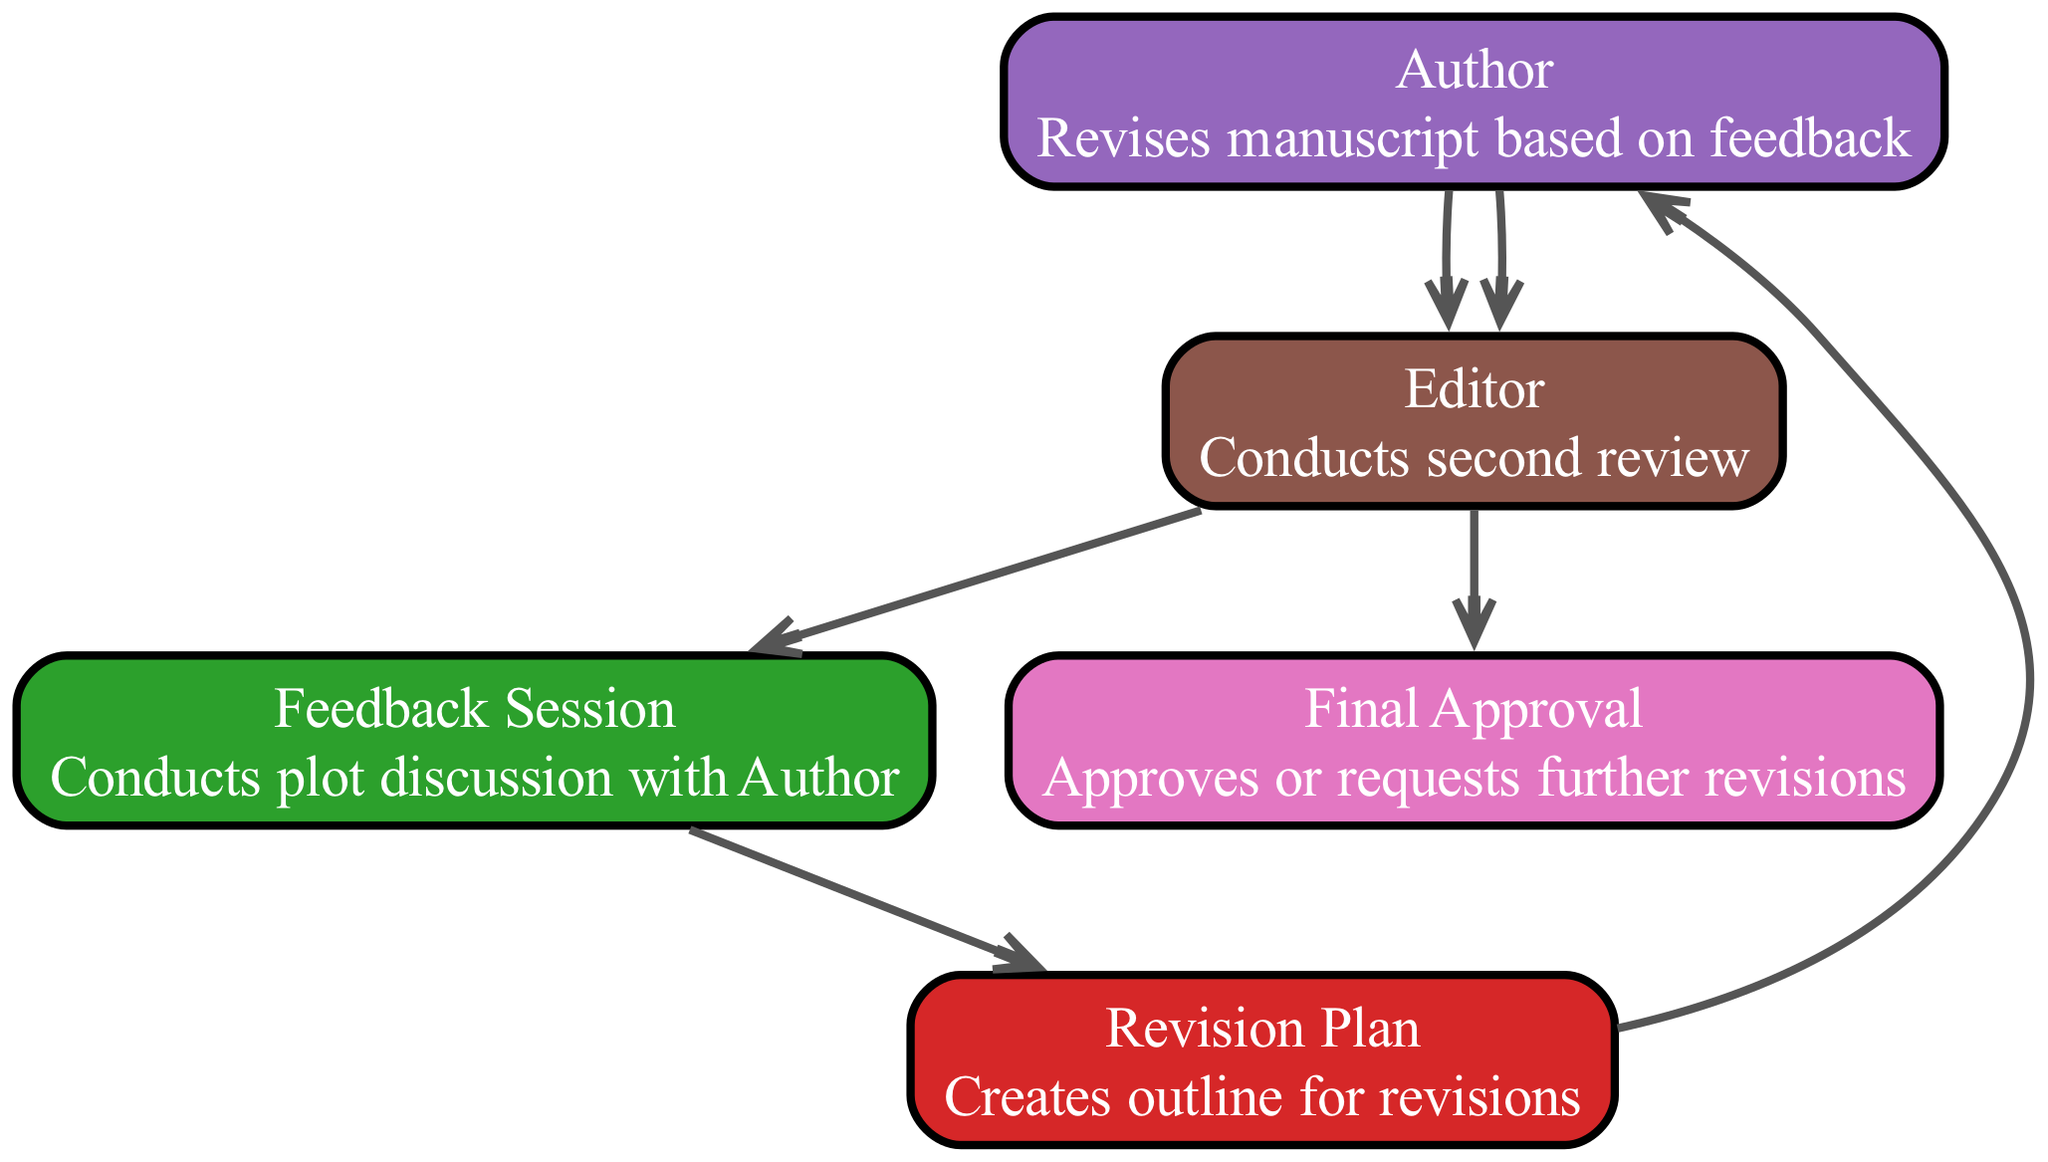What is the first action taken in the workflow? The first action in the diagram is by the Author, who submits the draft manuscript. This can be determined by looking at the starting node, which shows the Author taking the initial step.
Answer: Submits draft manuscript How many total elements are in the sequence diagram? By counting all the defined elements in the diagram, there are seven elements showcasing different actions by the Author, Editor, Feedback Session, Revision Plan, and Final Approval.
Answer: 7 What action follows the revision plan in the workflow? The action that follows the Revision Plan is the Author revises the manuscript based on feedback. This can be verified by examining the edges connecting the nodes.
Answer: Revises manuscript based on feedback Which element acts as a decision point in the workflow? The Final Approval acts as a decision point, as it either approves or requests further revisions based on the previous actions. This is indicated by it being the last element connected decisively to prior actions.
Answer: Final Approval Who conducts the second review in the diagram? The second review is conducted by the Editor. This is evident as the Editor is connected to the action following the Author's revision.
Answer: Editor Which two actions are repeated in the sequence diagram? The actions of reviewing and revising are repeated, where the Editor reviews the plot structure and then conducts a second review after the Author revises the manuscript. This pattern indicates a cyclical nature in the workflow.
Answer: Reviewing and revising What is the final possible outcome of the workflow? The final possible outcome is the approval of the manuscript or a request for further revisions. This can be inferred from the last interaction in the sequence, where the Final Approval either approves or requests changes.
Answer: Approves or requests further revisions What relationship exists between the Author and the Feedback Session? The relationship is that the Feedback Session conducts a plot discussion with the Author after the Editor reviews the plot structure. This can be traced by following the arrows in the diagram from the Editor to the Feedback Session and then to the Author.
Answer: Conducts plot discussion with Author 